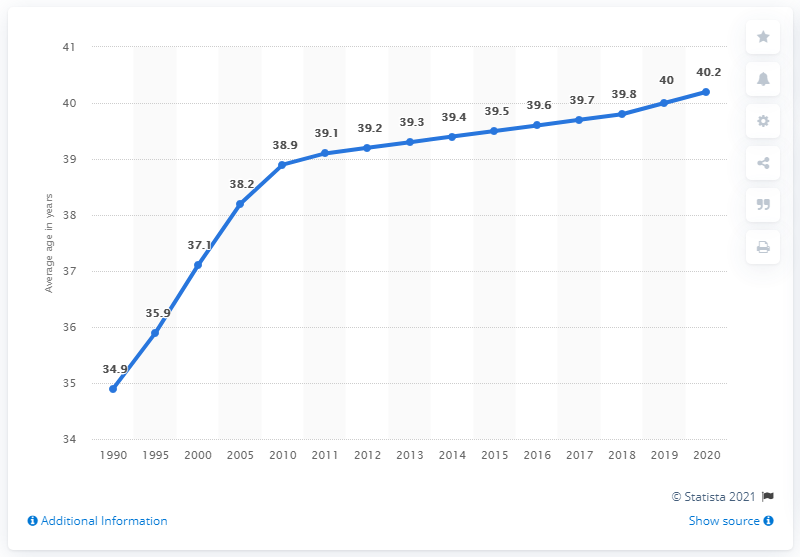Highlight a few significant elements in this photo. According to data from 1990, the average age of the Russian population was 34.9 years. The average age of the Russian population between the years 1990 and 2019 was 5.1. 